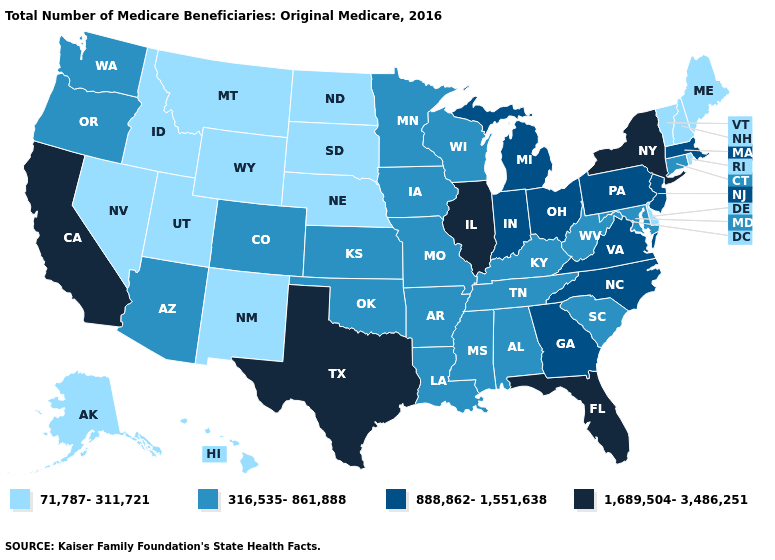Name the states that have a value in the range 1,689,504-3,486,251?
Quick response, please. California, Florida, Illinois, New York, Texas. What is the lowest value in states that border South Carolina?
Answer briefly. 888,862-1,551,638. What is the value of Idaho?
Write a very short answer. 71,787-311,721. What is the highest value in the West ?
Be succinct. 1,689,504-3,486,251. What is the highest value in the Northeast ?
Give a very brief answer. 1,689,504-3,486,251. Does California have the lowest value in the West?
Answer briefly. No. What is the highest value in the USA?
Be succinct. 1,689,504-3,486,251. Name the states that have a value in the range 316,535-861,888?
Quick response, please. Alabama, Arizona, Arkansas, Colorado, Connecticut, Iowa, Kansas, Kentucky, Louisiana, Maryland, Minnesota, Mississippi, Missouri, Oklahoma, Oregon, South Carolina, Tennessee, Washington, West Virginia, Wisconsin. Name the states that have a value in the range 1,689,504-3,486,251?
Give a very brief answer. California, Florida, Illinois, New York, Texas. What is the value of Maine?
Give a very brief answer. 71,787-311,721. Which states have the lowest value in the West?
Answer briefly. Alaska, Hawaii, Idaho, Montana, Nevada, New Mexico, Utah, Wyoming. Name the states that have a value in the range 1,689,504-3,486,251?
Keep it brief. California, Florida, Illinois, New York, Texas. Name the states that have a value in the range 71,787-311,721?
Concise answer only. Alaska, Delaware, Hawaii, Idaho, Maine, Montana, Nebraska, Nevada, New Hampshire, New Mexico, North Dakota, Rhode Island, South Dakota, Utah, Vermont, Wyoming. Does the map have missing data?
Be succinct. No. Is the legend a continuous bar?
Answer briefly. No. 